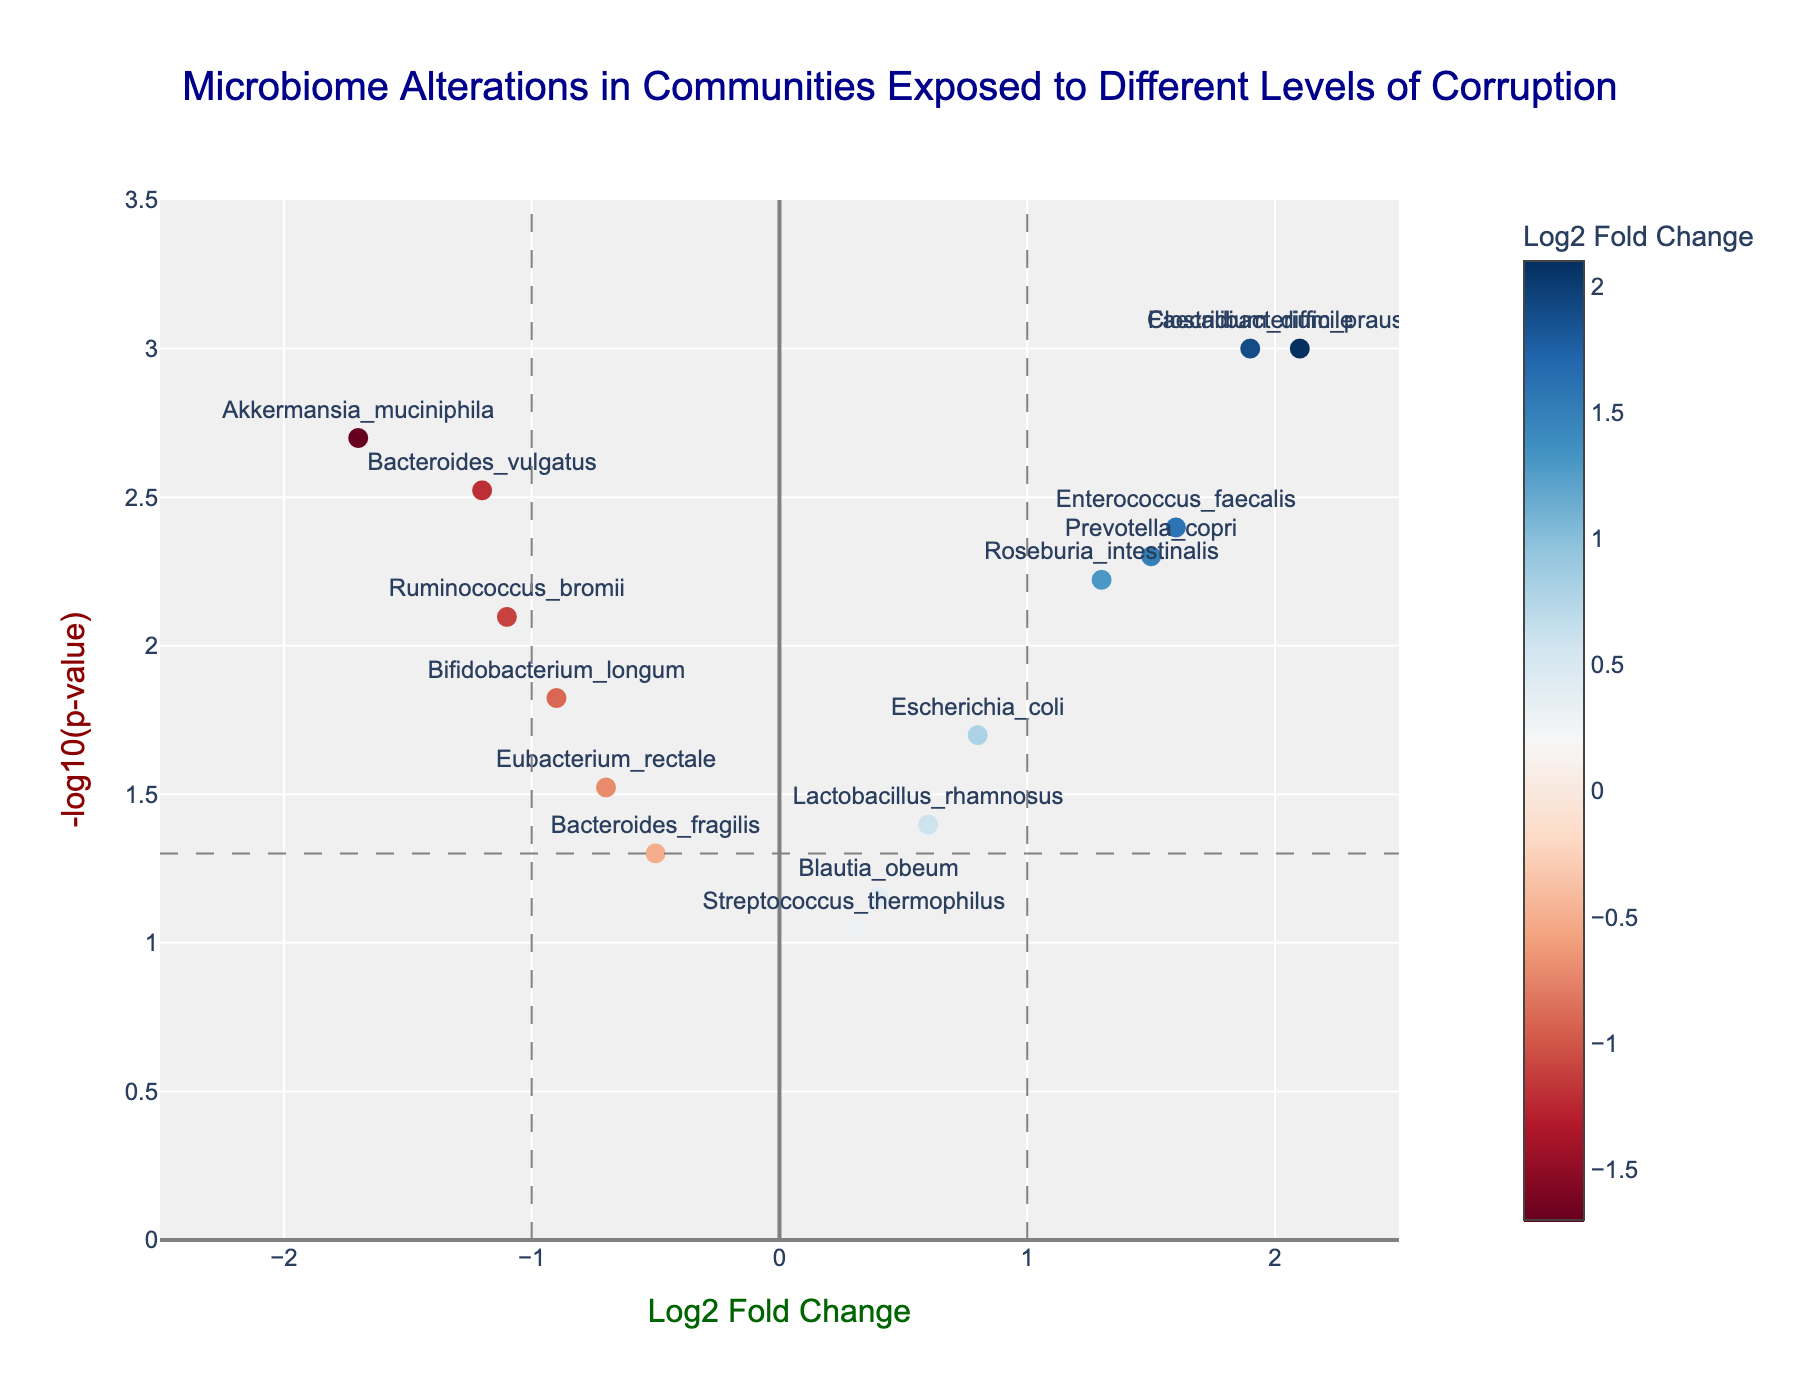What's the title of the plot? The title is located at the top of the plot.
Answer: Microbiome Alterations in Communities Exposed to Different Levels of Corruption How many microbe data points are displayed in the plot? Count the number of markers representing different microbes on the plot. There should be 15 markers as there are 15 microbes in the provided data.
Answer: 15 Which microbe has the highest -log10(p-value)? The highest -log10(p-value) value can be identified by finding the highest y-axis point on the plot. The marker labeled "Faecalibacterium_prausnitzii" is the highest.
Answer: Faecalibacterium_prausnitzii Which microbes have a Log2FoldChange above 1 and are statistically significant (p < 0.05)? Look for markers with a Log2FoldChange greater than 1 (right side of the plot) and above the horizontal line at -log10(p) = -log10(0.05). These will be above 1 on the y-axis. The microbes are "Faecalibacterium_prausnitzii," "Prevotella_copri," "Clostridium_difficile," and "Enterococcus_faecalis".
Answer: Faecalibacterium_prausnitzii, Prevotella_copri, Clostridium_difficile, Enterococcus_faecalis What is the Log2FoldChange range represented in the plot? Identify the minimum and maximum values on the x-axis. The range on the x-axis goes from -2.5 to 2.5.
Answer: -2.5 to 2.5 Which microbe has the largest negative Log2FoldChange value, and what is its -log10(p-value)? Find the leftmost point on the x-axis, with the corresponding microbe label. The marker labeled "Akkermansia_muciniphila" has the largest negative Log2FoldChange value. To find its -log10(p-value), locate its position on the y-axis.
Answer: Akkermansia_muciniphila, -log10(p) = 2.70 Identify the microbes that are close to the threshold of significance (p = 0.05) based on -log10(p-value). Look at the horizontal line at -log10(p) = -log10(0.05) and identify the points just above or below this line. The microbes "Eubacterium_rectale" and "Bacteroides_fragilis" are around this threshold.
Answer: Eubacterium_rectale, Bacteroides_fragilis Which microbes have both statistical significance and positive Log2FoldChange? Identify the points on the right side of the plot (positive Log2FoldChange) and above the threshold for -log10(p), indicating statistical significance. The microbes meeting these criteria are "Faecalibacterium_prausnitzii," "Prevotella_copri," "Clostridium_difficile," and "Enterococcus_faecalis."
Answer: Faecalibacterium_prausnitzii, Prevotella_copri, Clostridium_difficile, Enterococcus_faecalis 